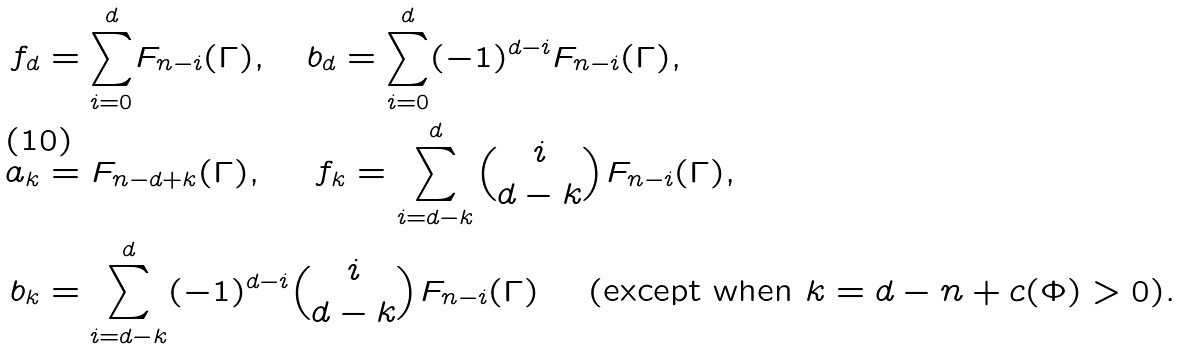Convert formula to latex. <formula><loc_0><loc_0><loc_500><loc_500>f _ { d } & = { { \sum ^ { d } _ { i = 0 } } } F _ { n - i } ( \Gamma ) , \quad b _ { d } = { { \sum ^ { d } _ { i = 0 } } } ( - 1 ) ^ { d - i } F _ { n - i } ( \Gamma ) , \\ a _ { k } & = F _ { n - d + k } ( \Gamma ) , \quad \ f _ { k } = { { \sum ^ { d } _ { i = d - k } } } { \binom { i } { d - k } } F _ { n - i } ( \Gamma ) , \\ b _ { k } & = { { \sum ^ { d } _ { i = d - k } } } ( - 1 ) ^ { d - i } { \binom { i } { d - k } } F _ { n - i } ( \Gamma ) \quad \text { (except when } k = d - n + c ( \Phi ) > 0 ) .</formula> 